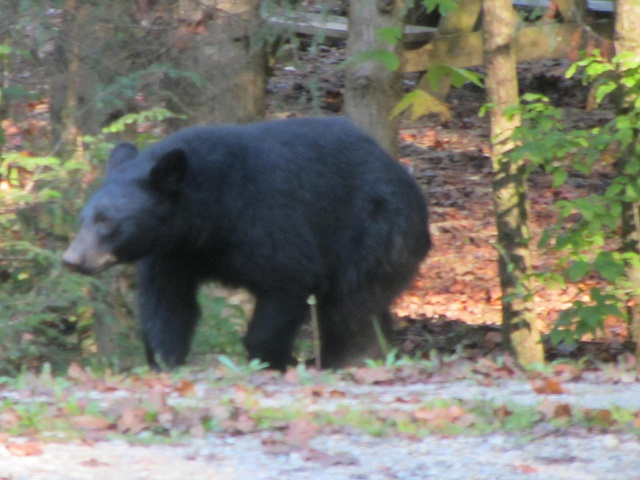Describe the objects in this image and their specific colors. I can see a bear in gray, black, and darkblue tones in this image. 